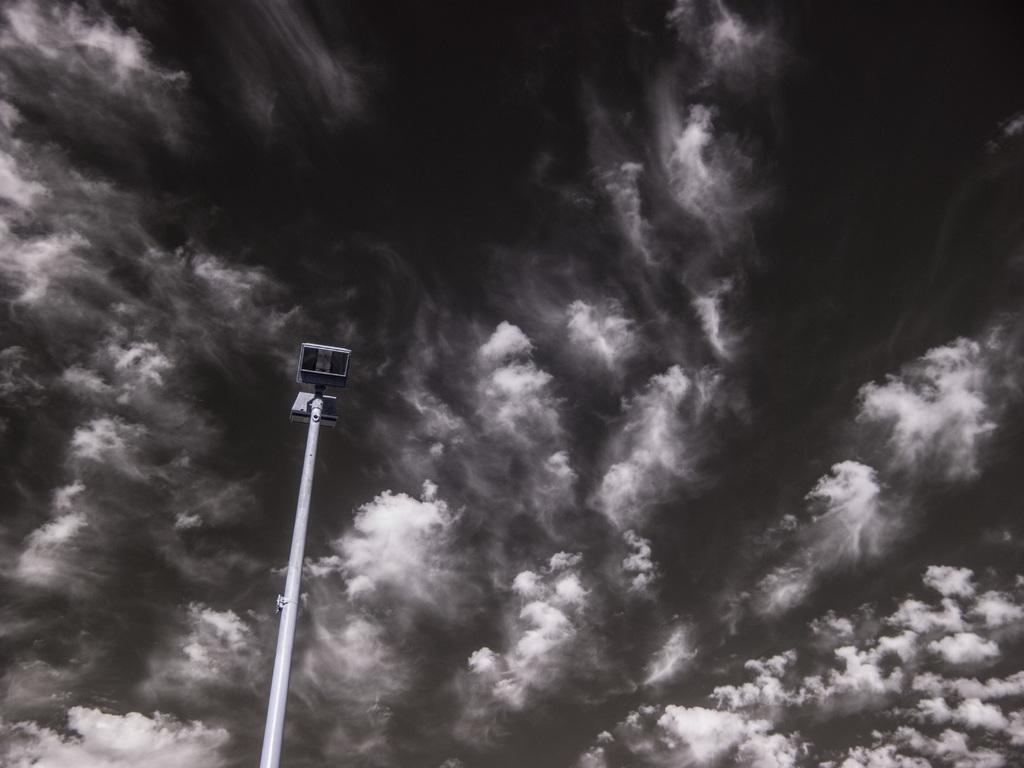Can you describe this image briefly? In this image I can see a light-pole. The image is in black and white. 